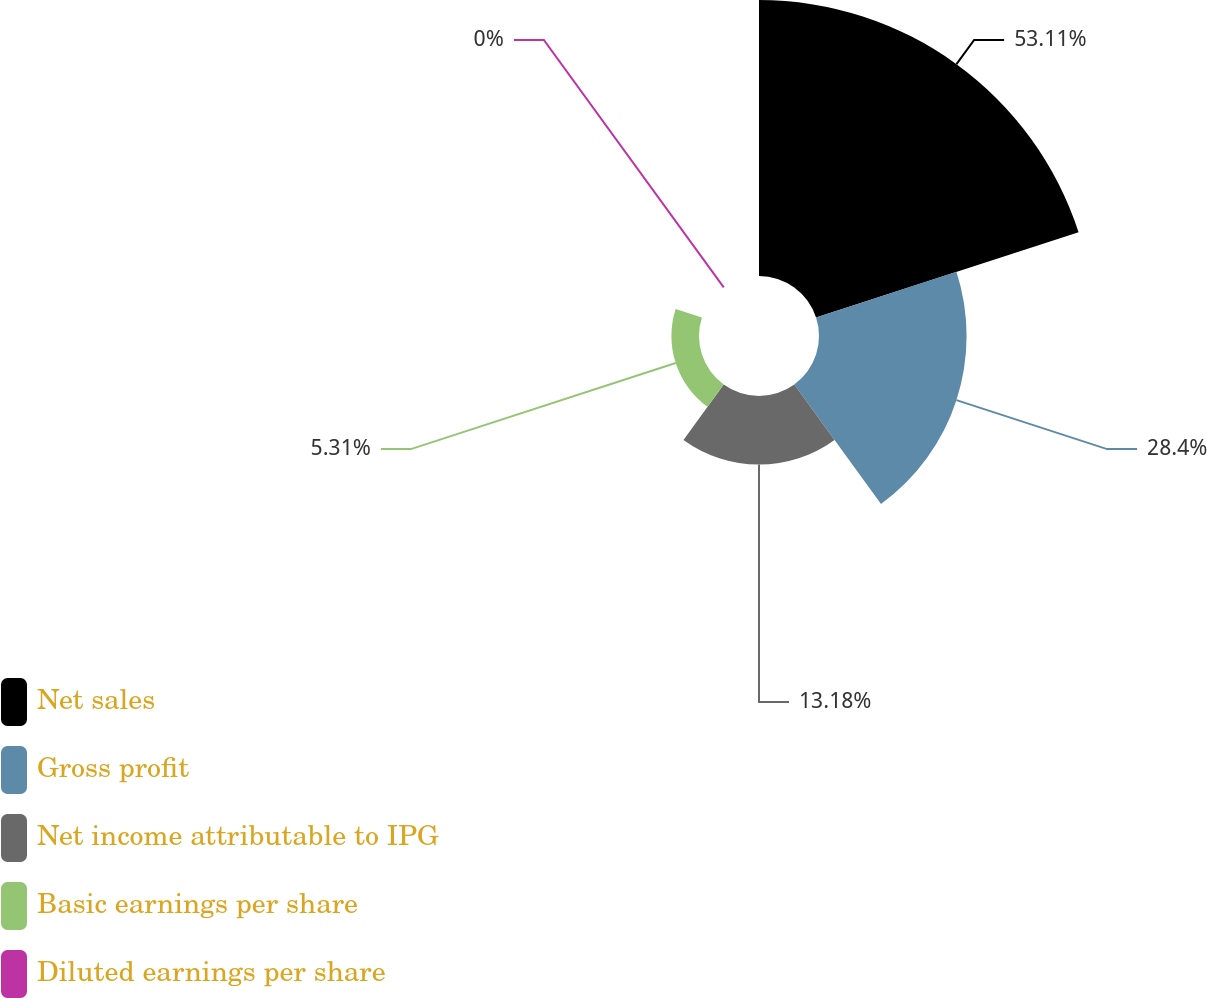Convert chart. <chart><loc_0><loc_0><loc_500><loc_500><pie_chart><fcel>Net sales<fcel>Gross profit<fcel>Net income attributable to IPG<fcel>Basic earnings per share<fcel>Diluted earnings per share<nl><fcel>53.11%<fcel>28.4%<fcel>13.18%<fcel>5.31%<fcel>0.0%<nl></chart> 